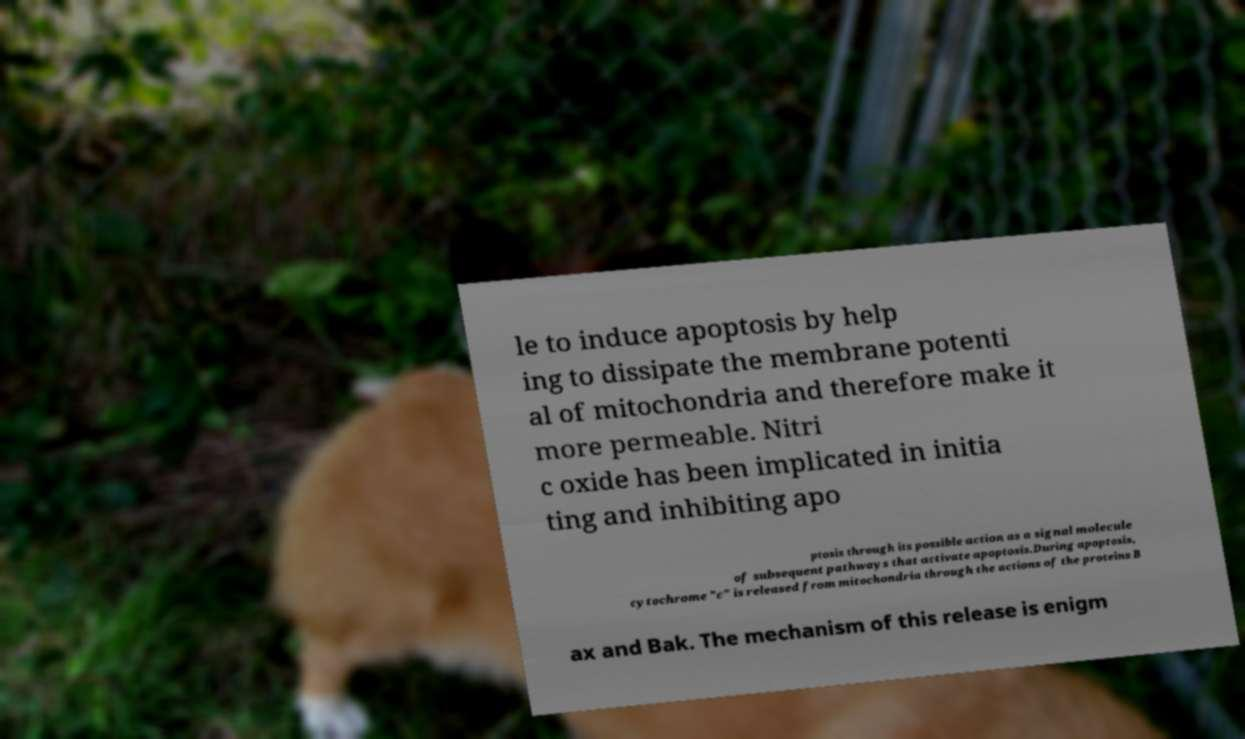Can you accurately transcribe the text from the provided image for me? le to induce apoptosis by help ing to dissipate the membrane potenti al of mitochondria and therefore make it more permeable. Nitri c oxide has been implicated in initia ting and inhibiting apo ptosis through its possible action as a signal molecule of subsequent pathways that activate apoptosis.During apoptosis, cytochrome "c" is released from mitochondria through the actions of the proteins B ax and Bak. The mechanism of this release is enigm 